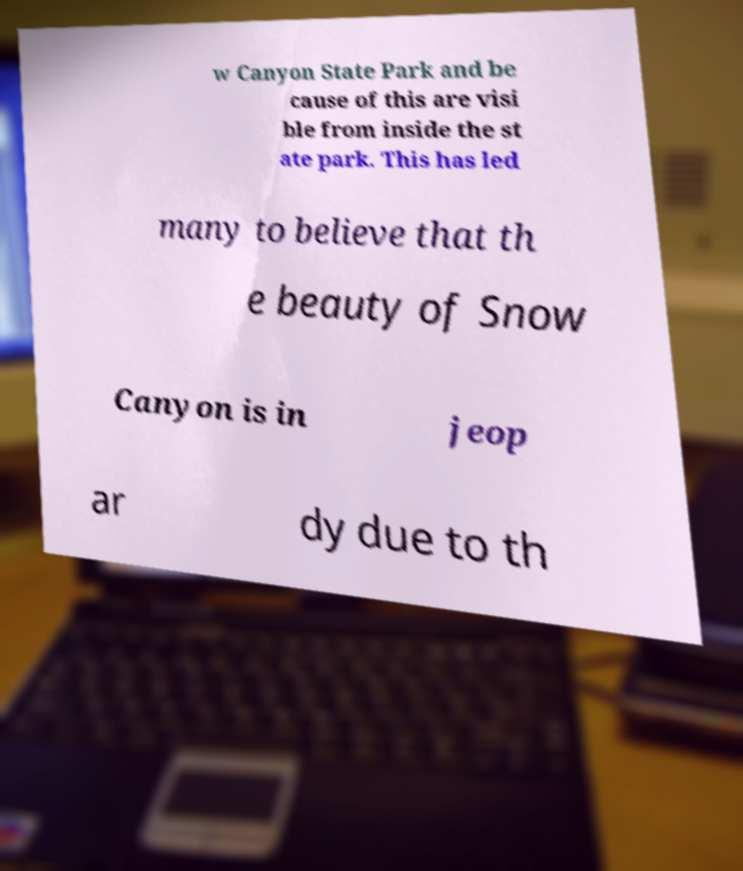Can you accurately transcribe the text from the provided image for me? w Canyon State Park and be cause of this are visi ble from inside the st ate park. This has led many to believe that th e beauty of Snow Canyon is in jeop ar dy due to th 